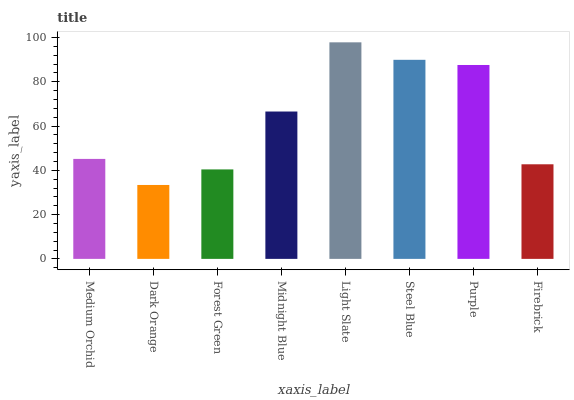Is Dark Orange the minimum?
Answer yes or no. Yes. Is Light Slate the maximum?
Answer yes or no. Yes. Is Forest Green the minimum?
Answer yes or no. No. Is Forest Green the maximum?
Answer yes or no. No. Is Forest Green greater than Dark Orange?
Answer yes or no. Yes. Is Dark Orange less than Forest Green?
Answer yes or no. Yes. Is Dark Orange greater than Forest Green?
Answer yes or no. No. Is Forest Green less than Dark Orange?
Answer yes or no. No. Is Midnight Blue the high median?
Answer yes or no. Yes. Is Medium Orchid the low median?
Answer yes or no. Yes. Is Dark Orange the high median?
Answer yes or no. No. Is Dark Orange the low median?
Answer yes or no. No. 